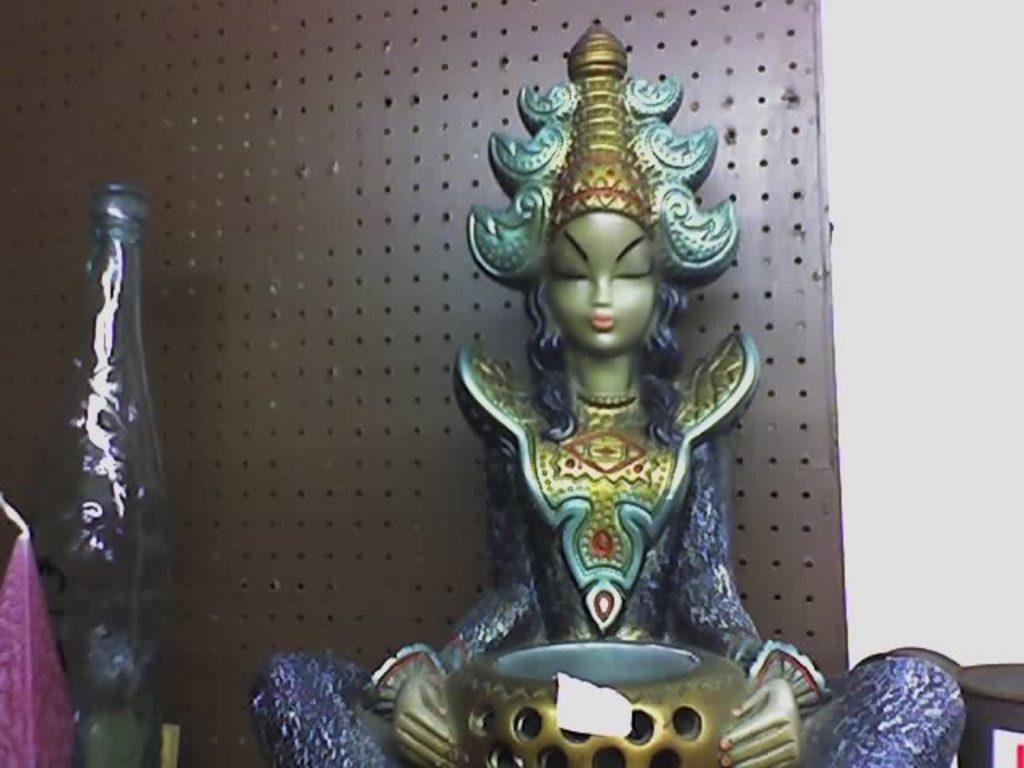Can you describe this image briefly? There is an idol which is blue in color and the background wall is brown. 